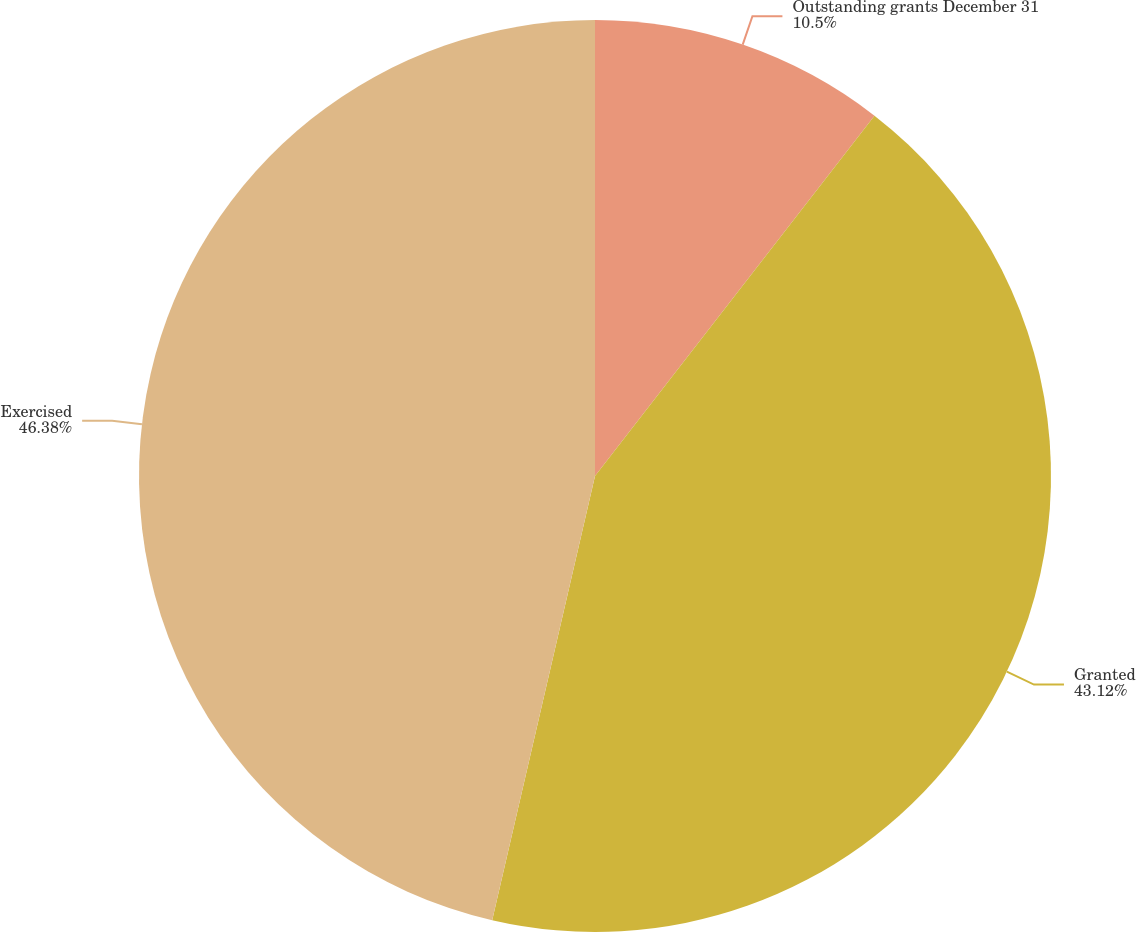Convert chart. <chart><loc_0><loc_0><loc_500><loc_500><pie_chart><fcel>Outstanding grants December 31<fcel>Granted<fcel>Exercised<nl><fcel>10.5%<fcel>43.12%<fcel>46.38%<nl></chart> 